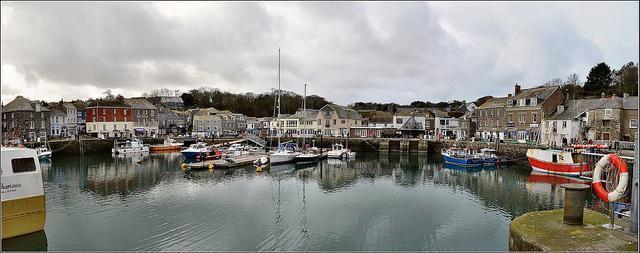How many big elephants are there?
Give a very brief answer. 0. 